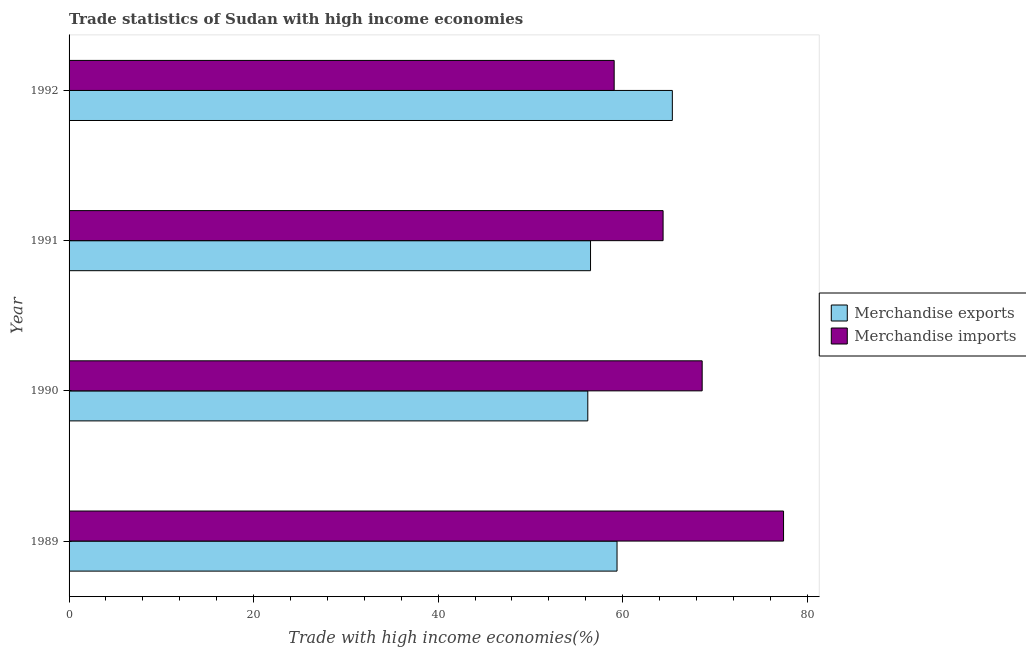Are the number of bars on each tick of the Y-axis equal?
Ensure brevity in your answer.  Yes. What is the merchandise exports in 1992?
Ensure brevity in your answer.  65.38. Across all years, what is the maximum merchandise exports?
Ensure brevity in your answer.  65.38. Across all years, what is the minimum merchandise imports?
Offer a very short reply. 59.07. In which year was the merchandise exports minimum?
Ensure brevity in your answer.  1990. What is the total merchandise exports in the graph?
Provide a succinct answer. 237.49. What is the difference between the merchandise exports in 1991 and that in 1992?
Give a very brief answer. -8.87. What is the difference between the merchandise exports in 1990 and the merchandise imports in 1992?
Offer a very short reply. -2.86. What is the average merchandise exports per year?
Provide a succinct answer. 59.37. In the year 1989, what is the difference between the merchandise exports and merchandise imports?
Offer a very short reply. -18.05. What is the ratio of the merchandise exports in 1989 to that in 1990?
Your answer should be compact. 1.06. Is the difference between the merchandise exports in 1989 and 1992 greater than the difference between the merchandise imports in 1989 and 1992?
Give a very brief answer. No. What is the difference between the highest and the second highest merchandise imports?
Ensure brevity in your answer.  8.82. What is the difference between the highest and the lowest merchandise imports?
Keep it short and to the point. 18.36. Is the sum of the merchandise exports in 1989 and 1990 greater than the maximum merchandise imports across all years?
Give a very brief answer. Yes. What does the 2nd bar from the top in 1992 represents?
Give a very brief answer. Merchandise exports. What does the 1st bar from the bottom in 1992 represents?
Offer a very short reply. Merchandise exports. How many bars are there?
Offer a terse response. 8. Are all the bars in the graph horizontal?
Provide a short and direct response. Yes. How many years are there in the graph?
Offer a terse response. 4. Are the values on the major ticks of X-axis written in scientific E-notation?
Your answer should be compact. No. Where does the legend appear in the graph?
Offer a very short reply. Center right. How many legend labels are there?
Your response must be concise. 2. What is the title of the graph?
Your response must be concise. Trade statistics of Sudan with high income economies. Does "2012 US$" appear as one of the legend labels in the graph?
Keep it short and to the point. No. What is the label or title of the X-axis?
Give a very brief answer. Trade with high income economies(%). What is the Trade with high income economies(%) of Merchandise exports in 1989?
Give a very brief answer. 59.38. What is the Trade with high income economies(%) in Merchandise imports in 1989?
Your answer should be very brief. 77.43. What is the Trade with high income economies(%) of Merchandise exports in 1990?
Ensure brevity in your answer.  56.22. What is the Trade with high income economies(%) in Merchandise imports in 1990?
Offer a terse response. 68.61. What is the Trade with high income economies(%) in Merchandise exports in 1991?
Offer a very short reply. 56.51. What is the Trade with high income economies(%) of Merchandise imports in 1991?
Keep it short and to the point. 64.38. What is the Trade with high income economies(%) of Merchandise exports in 1992?
Ensure brevity in your answer.  65.38. What is the Trade with high income economies(%) of Merchandise imports in 1992?
Provide a short and direct response. 59.07. Across all years, what is the maximum Trade with high income economies(%) of Merchandise exports?
Keep it short and to the point. 65.38. Across all years, what is the maximum Trade with high income economies(%) of Merchandise imports?
Provide a succinct answer. 77.43. Across all years, what is the minimum Trade with high income economies(%) of Merchandise exports?
Provide a short and direct response. 56.22. Across all years, what is the minimum Trade with high income economies(%) in Merchandise imports?
Your response must be concise. 59.07. What is the total Trade with high income economies(%) in Merchandise exports in the graph?
Make the answer very short. 237.49. What is the total Trade with high income economies(%) of Merchandise imports in the graph?
Your answer should be very brief. 269.49. What is the difference between the Trade with high income economies(%) in Merchandise exports in 1989 and that in 1990?
Offer a very short reply. 3.17. What is the difference between the Trade with high income economies(%) of Merchandise imports in 1989 and that in 1990?
Make the answer very short. 8.82. What is the difference between the Trade with high income economies(%) in Merchandise exports in 1989 and that in 1991?
Provide a succinct answer. 2.87. What is the difference between the Trade with high income economies(%) in Merchandise imports in 1989 and that in 1991?
Provide a short and direct response. 13.05. What is the difference between the Trade with high income economies(%) in Merchandise exports in 1989 and that in 1992?
Offer a very short reply. -5.99. What is the difference between the Trade with high income economies(%) of Merchandise imports in 1989 and that in 1992?
Offer a very short reply. 18.36. What is the difference between the Trade with high income economies(%) in Merchandise exports in 1990 and that in 1991?
Offer a very short reply. -0.3. What is the difference between the Trade with high income economies(%) in Merchandise imports in 1990 and that in 1991?
Provide a succinct answer. 4.24. What is the difference between the Trade with high income economies(%) of Merchandise exports in 1990 and that in 1992?
Your answer should be very brief. -9.16. What is the difference between the Trade with high income economies(%) of Merchandise imports in 1990 and that in 1992?
Your answer should be very brief. 9.54. What is the difference between the Trade with high income economies(%) of Merchandise exports in 1991 and that in 1992?
Make the answer very short. -8.87. What is the difference between the Trade with high income economies(%) of Merchandise imports in 1991 and that in 1992?
Ensure brevity in your answer.  5.3. What is the difference between the Trade with high income economies(%) in Merchandise exports in 1989 and the Trade with high income economies(%) in Merchandise imports in 1990?
Give a very brief answer. -9.23. What is the difference between the Trade with high income economies(%) in Merchandise exports in 1989 and the Trade with high income economies(%) in Merchandise imports in 1991?
Give a very brief answer. -4.99. What is the difference between the Trade with high income economies(%) in Merchandise exports in 1989 and the Trade with high income economies(%) in Merchandise imports in 1992?
Provide a short and direct response. 0.31. What is the difference between the Trade with high income economies(%) in Merchandise exports in 1990 and the Trade with high income economies(%) in Merchandise imports in 1991?
Make the answer very short. -8.16. What is the difference between the Trade with high income economies(%) of Merchandise exports in 1990 and the Trade with high income economies(%) of Merchandise imports in 1992?
Ensure brevity in your answer.  -2.86. What is the difference between the Trade with high income economies(%) in Merchandise exports in 1991 and the Trade with high income economies(%) in Merchandise imports in 1992?
Ensure brevity in your answer.  -2.56. What is the average Trade with high income economies(%) of Merchandise exports per year?
Provide a succinct answer. 59.37. What is the average Trade with high income economies(%) of Merchandise imports per year?
Offer a terse response. 67.37. In the year 1989, what is the difference between the Trade with high income economies(%) of Merchandise exports and Trade with high income economies(%) of Merchandise imports?
Ensure brevity in your answer.  -18.05. In the year 1990, what is the difference between the Trade with high income economies(%) of Merchandise exports and Trade with high income economies(%) of Merchandise imports?
Make the answer very short. -12.4. In the year 1991, what is the difference between the Trade with high income economies(%) of Merchandise exports and Trade with high income economies(%) of Merchandise imports?
Provide a succinct answer. -7.86. In the year 1992, what is the difference between the Trade with high income economies(%) of Merchandise exports and Trade with high income economies(%) of Merchandise imports?
Provide a short and direct response. 6.3. What is the ratio of the Trade with high income economies(%) in Merchandise exports in 1989 to that in 1990?
Ensure brevity in your answer.  1.06. What is the ratio of the Trade with high income economies(%) in Merchandise imports in 1989 to that in 1990?
Provide a succinct answer. 1.13. What is the ratio of the Trade with high income economies(%) of Merchandise exports in 1989 to that in 1991?
Offer a terse response. 1.05. What is the ratio of the Trade with high income economies(%) of Merchandise imports in 1989 to that in 1991?
Your answer should be compact. 1.2. What is the ratio of the Trade with high income economies(%) of Merchandise exports in 1989 to that in 1992?
Your response must be concise. 0.91. What is the ratio of the Trade with high income economies(%) of Merchandise imports in 1989 to that in 1992?
Ensure brevity in your answer.  1.31. What is the ratio of the Trade with high income economies(%) in Merchandise exports in 1990 to that in 1991?
Provide a short and direct response. 0.99. What is the ratio of the Trade with high income economies(%) of Merchandise imports in 1990 to that in 1991?
Your response must be concise. 1.07. What is the ratio of the Trade with high income economies(%) in Merchandise exports in 1990 to that in 1992?
Provide a short and direct response. 0.86. What is the ratio of the Trade with high income economies(%) of Merchandise imports in 1990 to that in 1992?
Your response must be concise. 1.16. What is the ratio of the Trade with high income economies(%) of Merchandise exports in 1991 to that in 1992?
Offer a very short reply. 0.86. What is the ratio of the Trade with high income economies(%) of Merchandise imports in 1991 to that in 1992?
Ensure brevity in your answer.  1.09. What is the difference between the highest and the second highest Trade with high income economies(%) of Merchandise exports?
Your response must be concise. 5.99. What is the difference between the highest and the second highest Trade with high income economies(%) in Merchandise imports?
Ensure brevity in your answer.  8.82. What is the difference between the highest and the lowest Trade with high income economies(%) of Merchandise exports?
Provide a succinct answer. 9.16. What is the difference between the highest and the lowest Trade with high income economies(%) of Merchandise imports?
Provide a succinct answer. 18.36. 